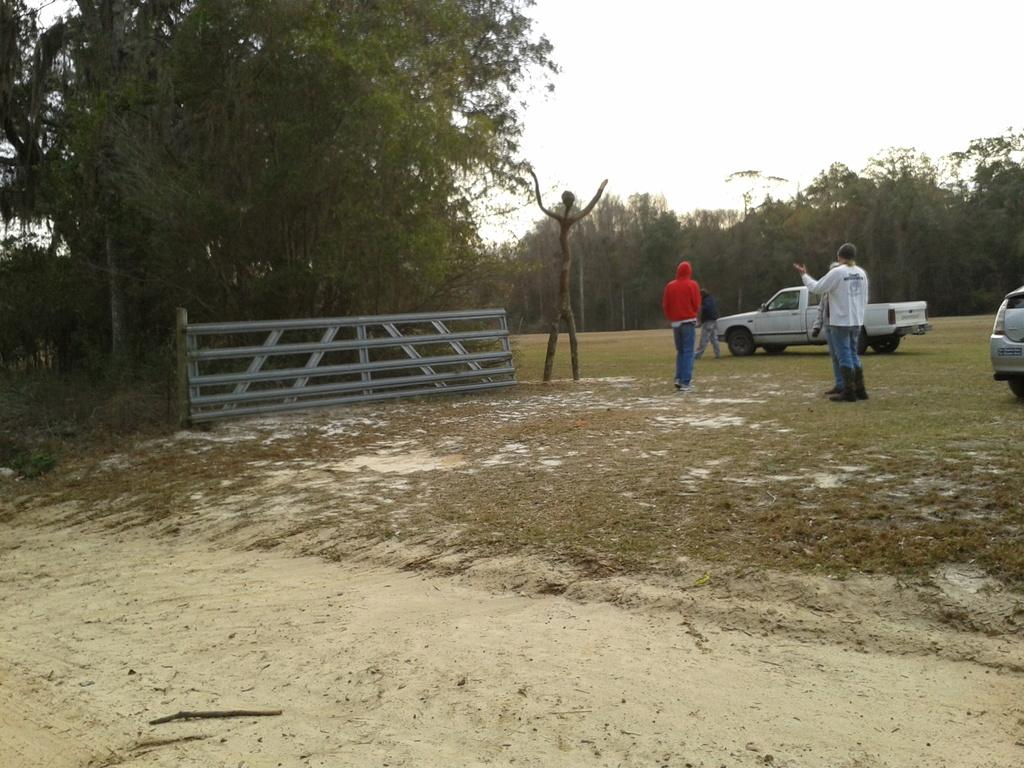Who or what is present in the image? There are people in the image. What can be seen on the right side of the image? There are cars on the right side of the image. What type of natural scenery is visible in the background of the image? There are trees visible in the background of the image. How many icicles are hanging from the people's clothing in the image? There are no icicles present in the image; it does not depict a cold or icy environment. 